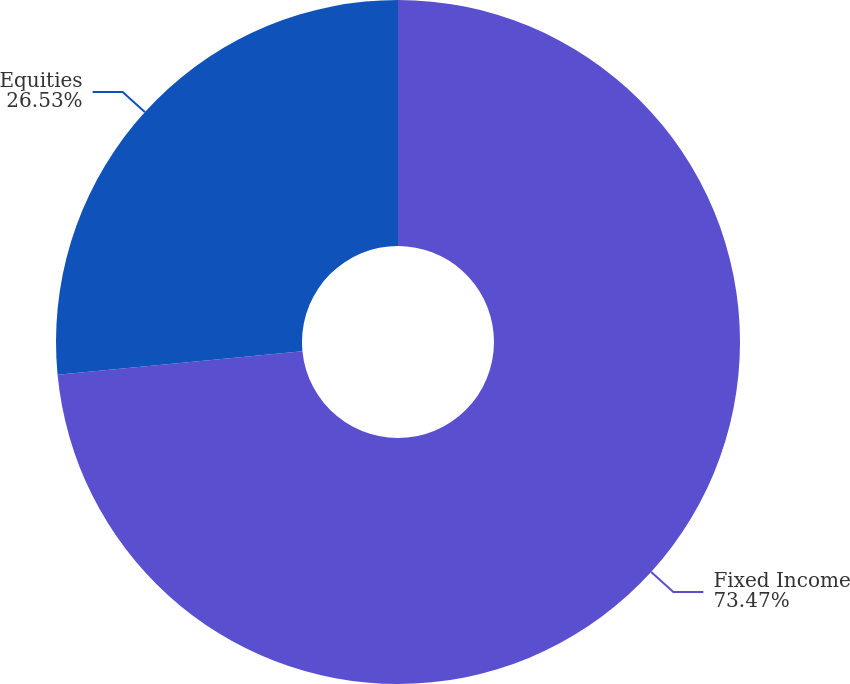Convert chart to OTSL. <chart><loc_0><loc_0><loc_500><loc_500><pie_chart><fcel>Fixed Income<fcel>Equities<nl><fcel>73.47%<fcel>26.53%<nl></chart> 